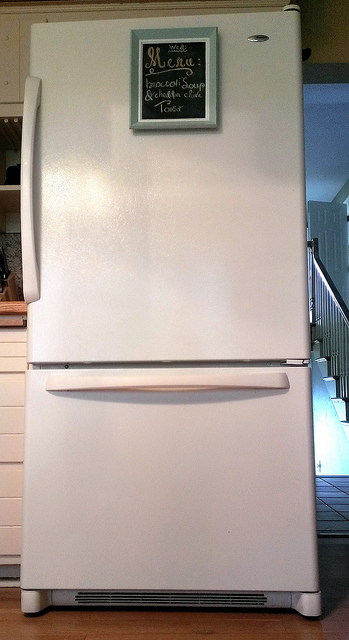Read and extract the text from this image. Menu broccoli TOAST Soup &amp; 